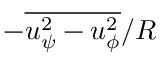<formula> <loc_0><loc_0><loc_500><loc_500>- \overline { { u _ { \psi } ^ { 2 } - u _ { \phi } ^ { 2 } } } / R</formula> 